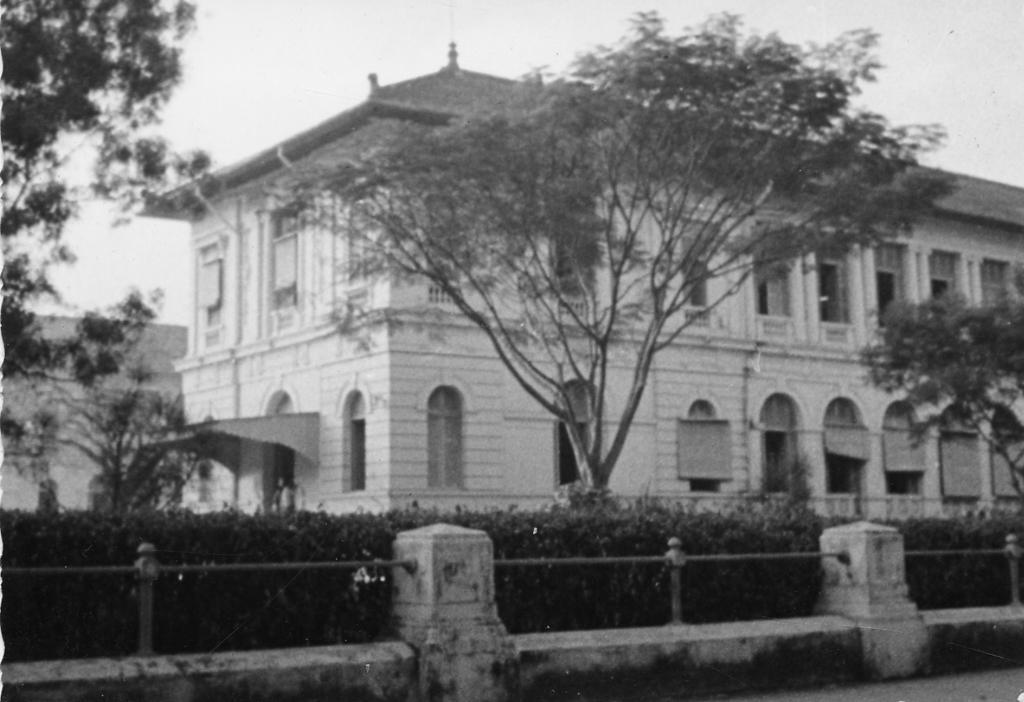Could you give a brief overview of what you see in this image? It is a black and white image. In this image we can see the building, trees and also shrubs. We can also see the barrier. Sky is also visible. 